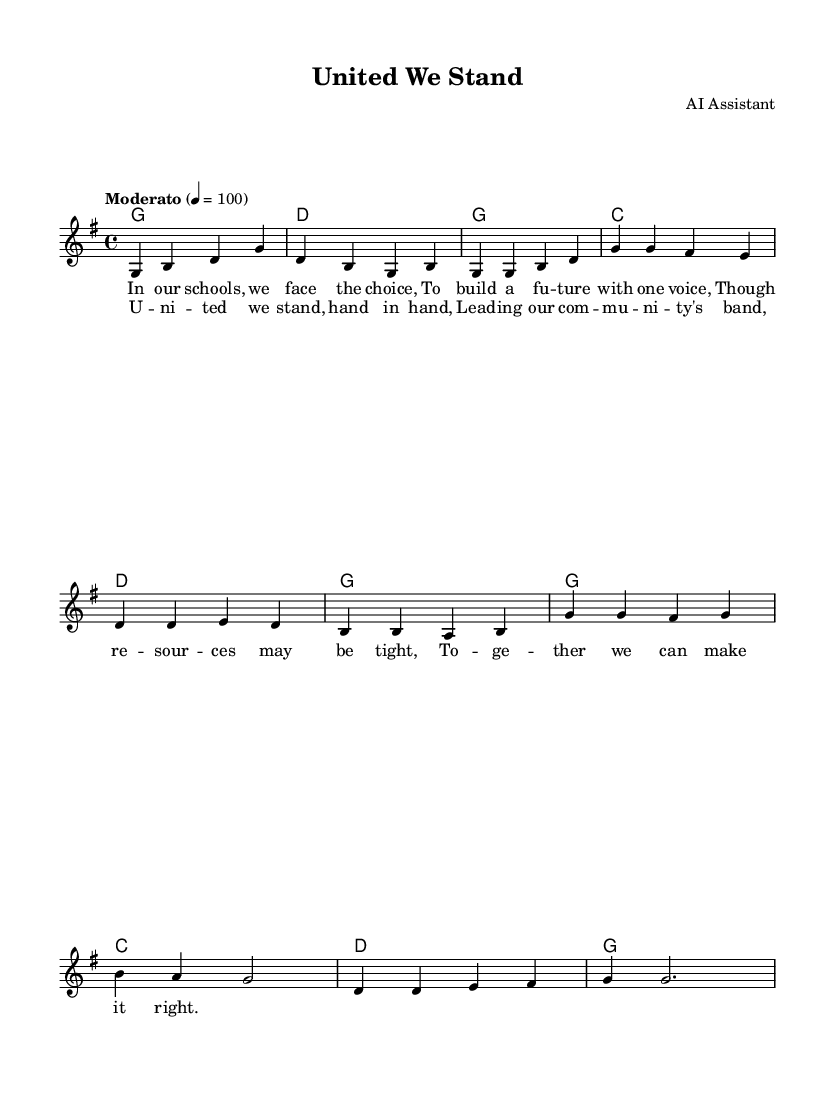What is the key signature of this music? The key signature is G major, which has one sharp (F#). This can be determined by looking at the beginning of the staff where the key signature is indicated.
Answer: G major What is the time signature of this music? The time signature is 4/4, which means there are four beats in each measure and the quarter note gets one beat. This is shown at the beginning of the staff after the key signature.
Answer: 4/4 What is the tempo marking of this music? The tempo marking is "Moderato" with a metronome marking of 100 beats per minute. This indicates a moderate tempo. This information is stated prominently at the beginning of the score.
Answer: Moderato 100 How many measures are in the intro section of the piece? The intro consists of two measures as indicated by the music notation before the verse starts. Each line typically contains a measure, and there are two indicated before the verse.
Answer: 2 How many unique chords are used in the chorus? The chorus uses three unique chords: G, C, and D. These chords can be identified in the chord symbols placed above the melody in the chorus section.
Answer: 3 What lyrical theme is conveyed in the first verse? The lyrical theme of the first verse focuses on unity and collaboration despite facing challenges, emphasizing the importance of collective effort. By analyzing the words sung in the verse, which reflects community values, this theme can be discerned.
Answer: Unity and collaboration What community-oriented message is highlighted in the chorus? The chorus celebrates solidarity and leadership within the community, conveyed through the phrase "United we stand, hand in hand." This indicates a call for togetherness in leadership, as depicted in the lyrics.
Answer: Solidarity and leadership 